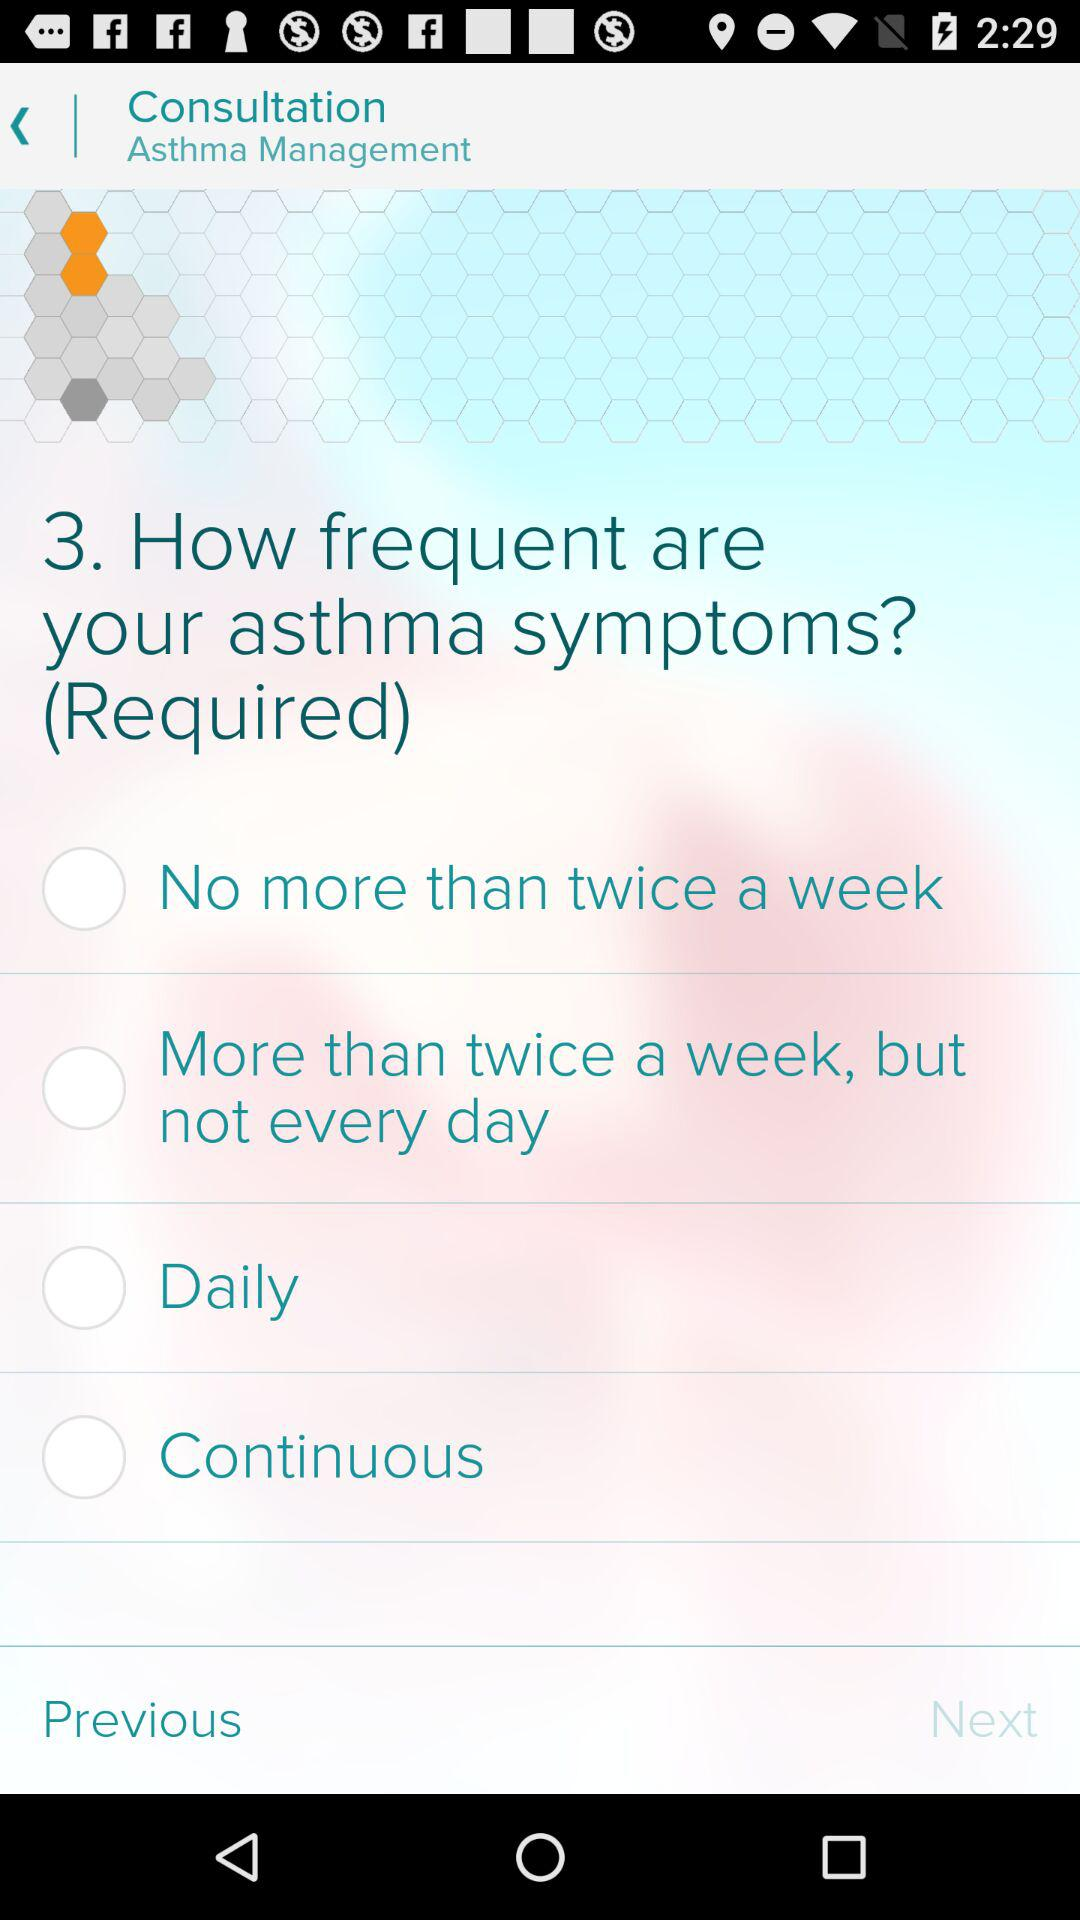How many options are there for how frequent the user's asthma symptoms are?
Answer the question using a single word or phrase. 4 